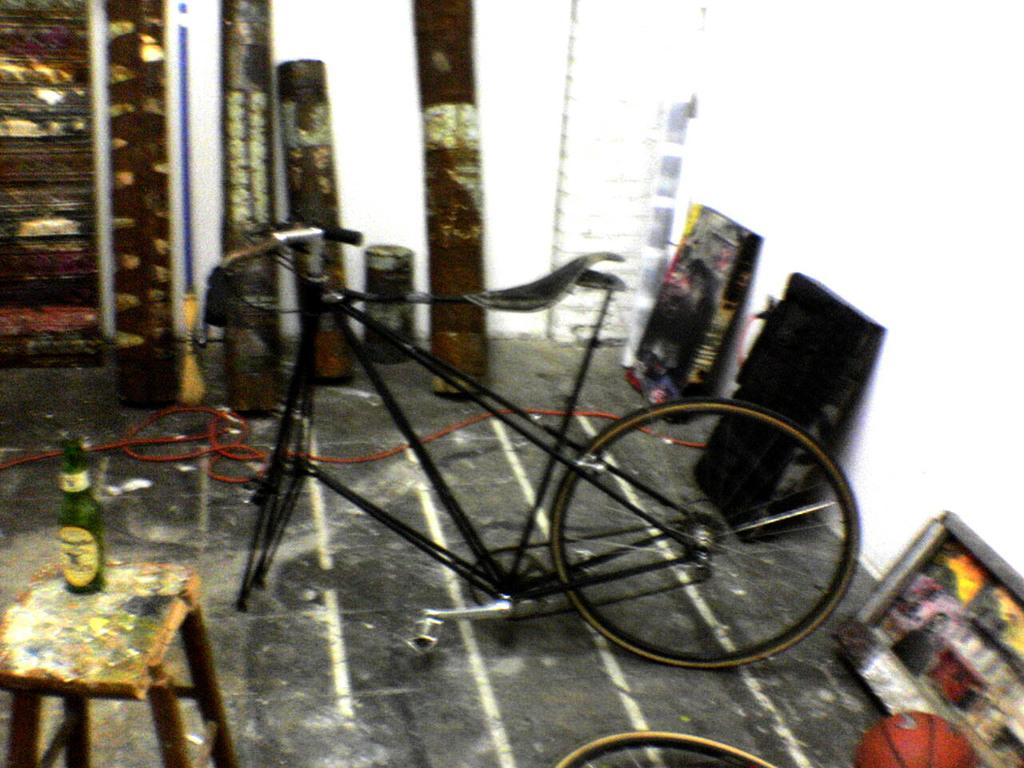What is placed on the stool in the image? There is a bottle on a stool in the image. What mode of transportation can be seen in the image? There is a bicycle in the image. What type of toy or plaything is present in the image? There is a ball in the image. What kind of structure or object is depicted in the image? There is a pipe in the image. What is visible on the floor in the image? There are objects on the floor in the image. What type of ship can be seen on the roof in the image? There is no ship or roof present in the image. What effect does the presence of the ball have on the pipe in the image? There is no interaction between the ball and the pipe in the image, so no effect can be observed. 